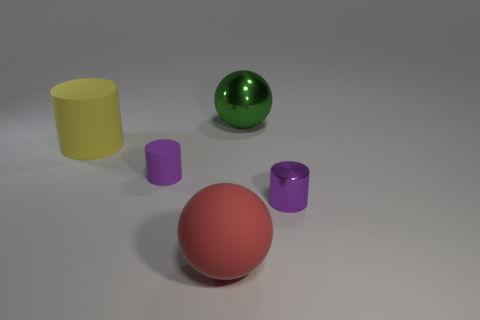Add 1 rubber spheres. How many objects exist? 6 Subtract all balls. How many objects are left? 3 Add 3 big yellow matte objects. How many big yellow matte objects are left? 4 Add 5 purple cylinders. How many purple cylinders exist? 7 Subtract 0 brown spheres. How many objects are left? 5 Subtract all red spheres. Subtract all rubber cylinders. How many objects are left? 2 